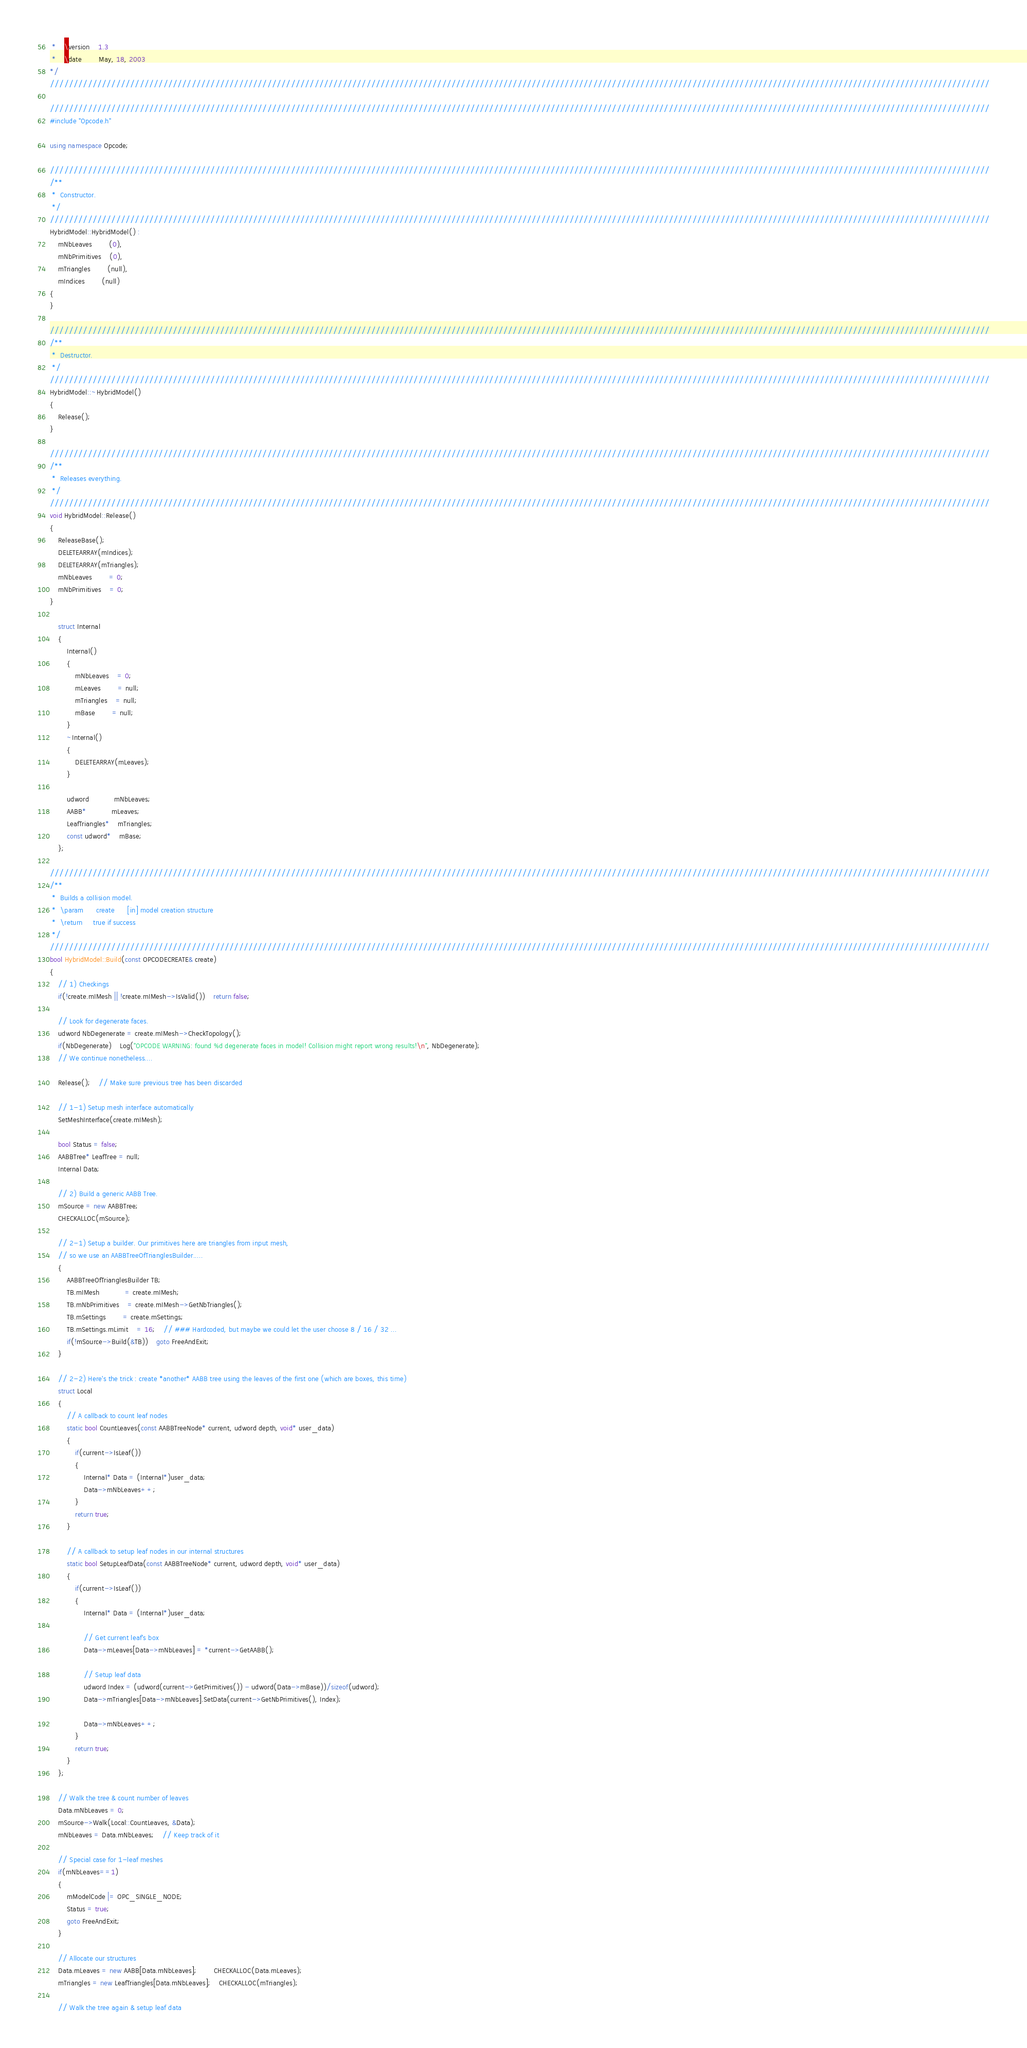<code> <loc_0><loc_0><loc_500><loc_500><_C++_> *	\version	1.3
 *	\date		May, 18, 2003
*/
///////////////////////////////////////////////////////////////////////////////////////////////////////////////////////////////////////////////////////////////////////////////////////////////////////

///////////////////////////////////////////////////////////////////////////////////////////////////////////////////////////////////////////////////////////////////////////////////////////////////////
#include "Opcode.h"

using namespace Opcode;

///////////////////////////////////////////////////////////////////////////////////////////////////////////////////////////////////////////////////////////////////////////////////////////////////////
/**
 *	Constructor.
 */
///////////////////////////////////////////////////////////////////////////////////////////////////////////////////////////////////////////////////////////////////////////////////////////////////////
HybridModel::HybridModel() :
	mNbLeaves		(0),
	mNbPrimitives	(0),
	mTriangles		(null),
	mIndices		(null)
{
}

///////////////////////////////////////////////////////////////////////////////////////////////////////////////////////////////////////////////////////////////////////////////////////////////////////
/**
 *	Destructor.
 */
///////////////////////////////////////////////////////////////////////////////////////////////////////////////////////////////////////////////////////////////////////////////////////////////////////
HybridModel::~HybridModel()
{
	Release();
}

///////////////////////////////////////////////////////////////////////////////////////////////////////////////////////////////////////////////////////////////////////////////////////////////////////
/**
 *	Releases everything.
 */
///////////////////////////////////////////////////////////////////////////////////////////////////////////////////////////////////////////////////////////////////////////////////////////////////////
void HybridModel::Release()
{
	ReleaseBase();
	DELETEARRAY(mIndices);
	DELETEARRAY(mTriangles);
	mNbLeaves		= 0;
	mNbPrimitives	= 0;
}

	struct Internal
	{
		Internal()
		{
			mNbLeaves	= 0;
			mLeaves		= null;
			mTriangles	= null;
			mBase		= null;
		}
		~Internal()
		{
			DELETEARRAY(mLeaves);
		}

		udword			mNbLeaves;
		AABB*			mLeaves;
		LeafTriangles*	mTriangles;
		const udword*	mBase;
	};

///////////////////////////////////////////////////////////////////////////////////////////////////////////////////////////////////////////////////////////////////////////////////////////////////////
/**
 *	Builds a collision model.
 *	\param		create		[in] model creation structure
 *	\return		true if success
 */
///////////////////////////////////////////////////////////////////////////////////////////////////////////////////////////////////////////////////////////////////////////////////////////////////////
bool HybridModel::Build(const OPCODECREATE& create)
{
	// 1) Checkings
	if(!create.mIMesh || !create.mIMesh->IsValid())	return false;

	// Look for degenerate faces.
	udword NbDegenerate = create.mIMesh->CheckTopology();
	if(NbDegenerate)	Log("OPCODE WARNING: found %d degenerate faces in model! Collision might report wrong results!\n", NbDegenerate);
	// We continue nonetheless.... 

	Release();	// Make sure previous tree has been discarded

	// 1-1) Setup mesh interface automatically
	SetMeshInterface(create.mIMesh);

	bool Status = false;
	AABBTree* LeafTree = null;
	Internal Data;

	// 2) Build a generic AABB Tree.
	mSource = new AABBTree;
	CHECKALLOC(mSource);

	// 2-1) Setup a builder. Our primitives here are triangles from input mesh,
	// so we use an AABBTreeOfTrianglesBuilder.....
	{
		AABBTreeOfTrianglesBuilder TB;
		TB.mIMesh			= create.mIMesh;
		TB.mNbPrimitives	= create.mIMesh->GetNbTriangles();
		TB.mSettings		= create.mSettings;
		TB.mSettings.mLimit	= 16;	// ### Hardcoded, but maybe we could let the user choose 8 / 16 / 32 ...
		if(!mSource->Build(&TB))	goto FreeAndExit;
	}

	// 2-2) Here's the trick : create *another* AABB tree using the leaves of the first one (which are boxes, this time)
	struct Local
	{
		// A callback to count leaf nodes
		static bool CountLeaves(const AABBTreeNode* current, udword depth, void* user_data)
		{
			if(current->IsLeaf())
			{
				Internal* Data = (Internal*)user_data;
				Data->mNbLeaves++;
			}
			return true;
		}

		// A callback to setup leaf nodes in our internal structures
		static bool SetupLeafData(const AABBTreeNode* current, udword depth, void* user_data)
		{
			if(current->IsLeaf())
			{
				Internal* Data = (Internal*)user_data;

				// Get current leaf's box
				Data->mLeaves[Data->mNbLeaves] = *current->GetAABB();

				// Setup leaf data
				udword Index = (udword(current->GetPrimitives()) - udword(Data->mBase))/sizeof(udword);
				Data->mTriangles[Data->mNbLeaves].SetData(current->GetNbPrimitives(), Index);

				Data->mNbLeaves++;
			}
			return true;
		}
	};

	// Walk the tree & count number of leaves
	Data.mNbLeaves = 0;
	mSource->Walk(Local::CountLeaves, &Data);
	mNbLeaves = Data.mNbLeaves;	// Keep track of it

	// Special case for 1-leaf meshes
	if(mNbLeaves==1)
	{
		mModelCode |= OPC_SINGLE_NODE;
		Status = true;
		goto FreeAndExit;
	}

	// Allocate our structures
	Data.mLeaves = new AABB[Data.mNbLeaves];		CHECKALLOC(Data.mLeaves);
	mTriangles = new LeafTriangles[Data.mNbLeaves];	CHECKALLOC(mTriangles);

	// Walk the tree again & setup leaf data</code> 